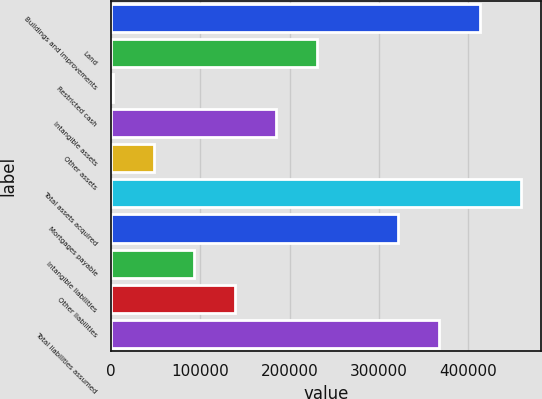Convert chart to OTSL. <chart><loc_0><loc_0><loc_500><loc_500><bar_chart><fcel>Buildings and improvements<fcel>Land<fcel>Restricted cash<fcel>Intangible assets<fcel>Other assets<fcel>Total assets acquired<fcel>Mortgages payable<fcel>Intangible liabilities<fcel>Other liabilities<fcel>Total liabilities assumed<nl><fcel>412930<fcel>230320<fcel>2056<fcel>184667<fcel>47708.7<fcel>458583<fcel>321625<fcel>93361.4<fcel>139014<fcel>367278<nl></chart> 